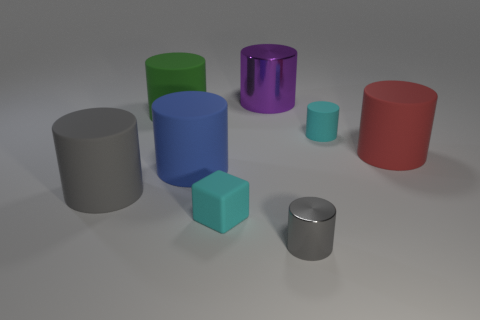Subtract all tiny cyan matte cylinders. How many cylinders are left? 6 Add 1 spheres. How many objects exist? 9 Subtract all purple cylinders. How many cylinders are left? 6 Subtract all cubes. How many objects are left? 7 Subtract all green cubes. How many gray cylinders are left? 2 Subtract 3 cylinders. How many cylinders are left? 4 Subtract all gray matte spheres. Subtract all cylinders. How many objects are left? 1 Add 8 red rubber things. How many red rubber things are left? 9 Add 2 small blocks. How many small blocks exist? 3 Subtract 0 brown cylinders. How many objects are left? 8 